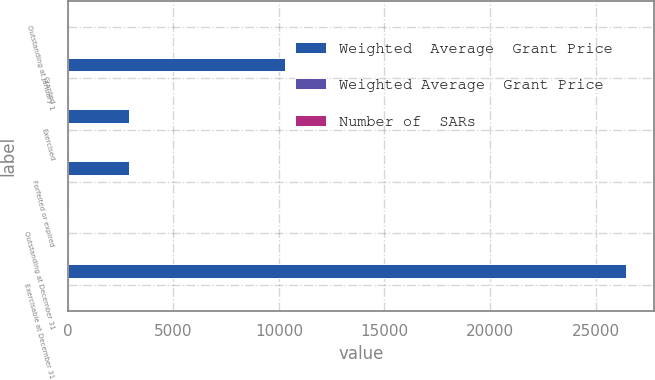Convert chart to OTSL. <chart><loc_0><loc_0><loc_500><loc_500><stacked_bar_chart><ecel><fcel>Outstanding at January 1<fcel>Granted<fcel>Exercised<fcel>Forfeited or expired<fcel>Outstanding at December 31<fcel>Exercisable at December 31<nl><fcel>Weighted  Average  Grant Price<fcel>21.99<fcel>10267<fcel>2904<fcel>2884<fcel>21.99<fcel>26462<nl><fcel>Weighted Average  Grant Price<fcel>20.41<fcel>16.16<fcel>11.18<fcel>21.78<fcel>19.98<fcel>24.14<nl><fcel>Number of  SARs<fcel>22.2<fcel>14.36<fcel>6.29<fcel>23.33<fcel>20.41<fcel>26.76<nl></chart> 